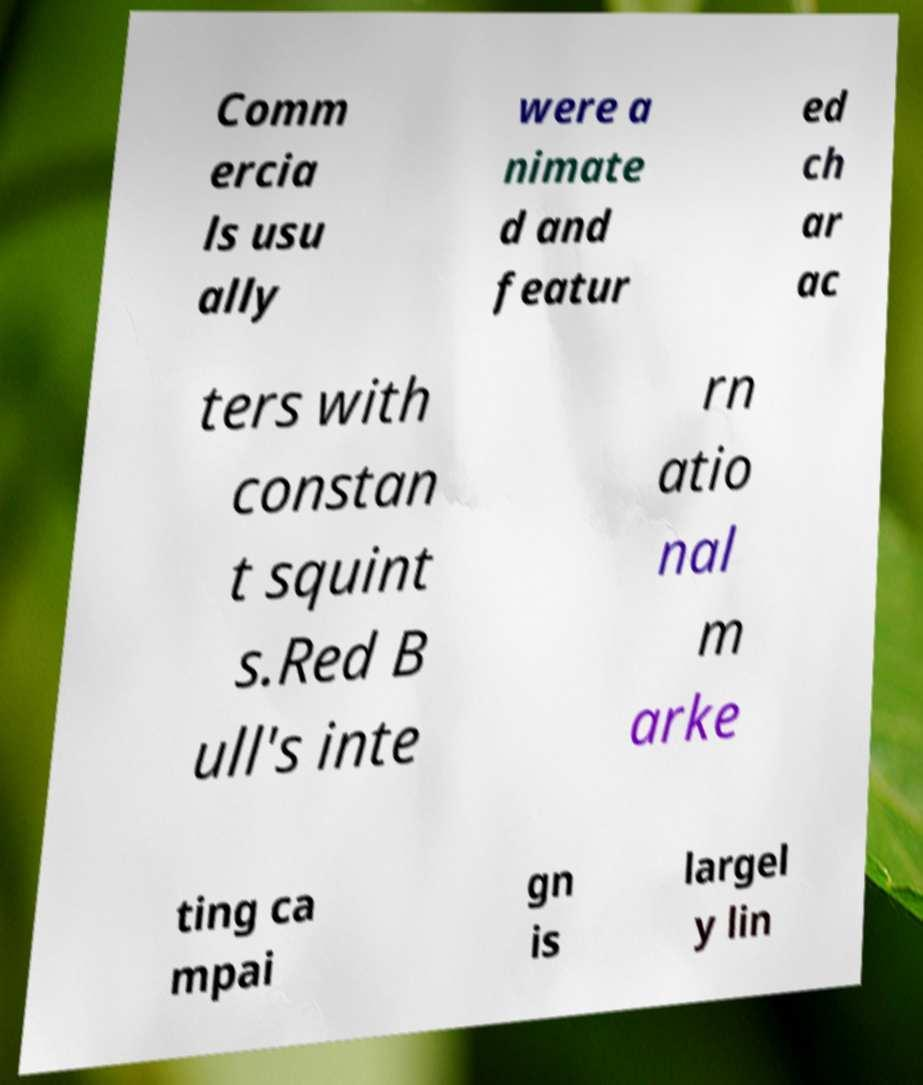Please identify and transcribe the text found in this image. Comm ercia ls usu ally were a nimate d and featur ed ch ar ac ters with constan t squint s.Red B ull's inte rn atio nal m arke ting ca mpai gn is largel y lin 